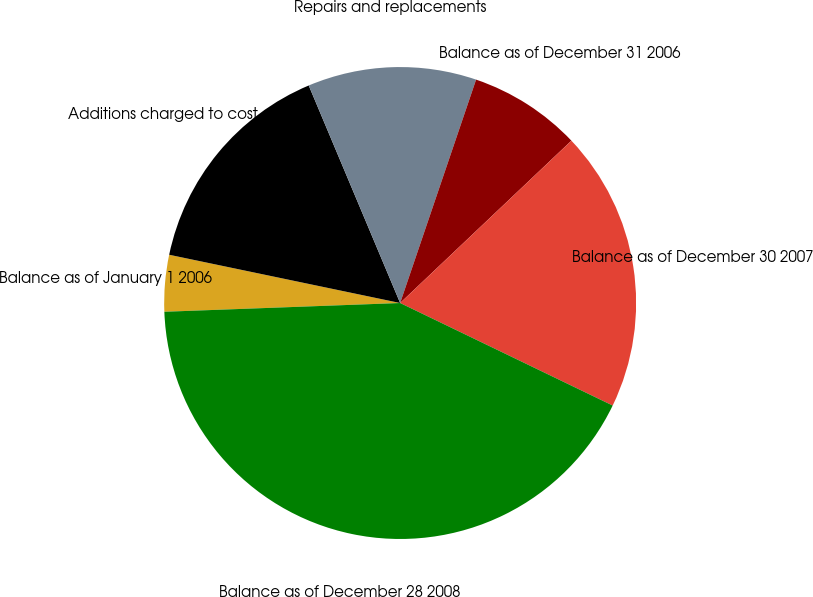<chart> <loc_0><loc_0><loc_500><loc_500><pie_chart><fcel>Balance as of January 1 2006<fcel>Additions charged to cost of<fcel>Repairs and replacements<fcel>Balance as of December 31 2006<fcel>Balance as of December 30 2007<fcel>Balance as of December 28 2008<nl><fcel>3.87%<fcel>15.39%<fcel>11.55%<fcel>7.71%<fcel>19.23%<fcel>42.26%<nl></chart> 